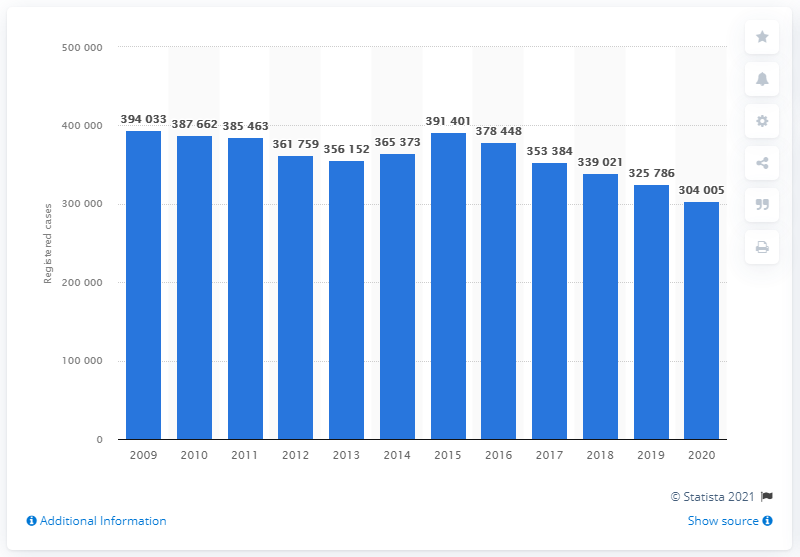Give some essential details in this illustration. Since 2015, the number of shoplifting cases has decreased. 